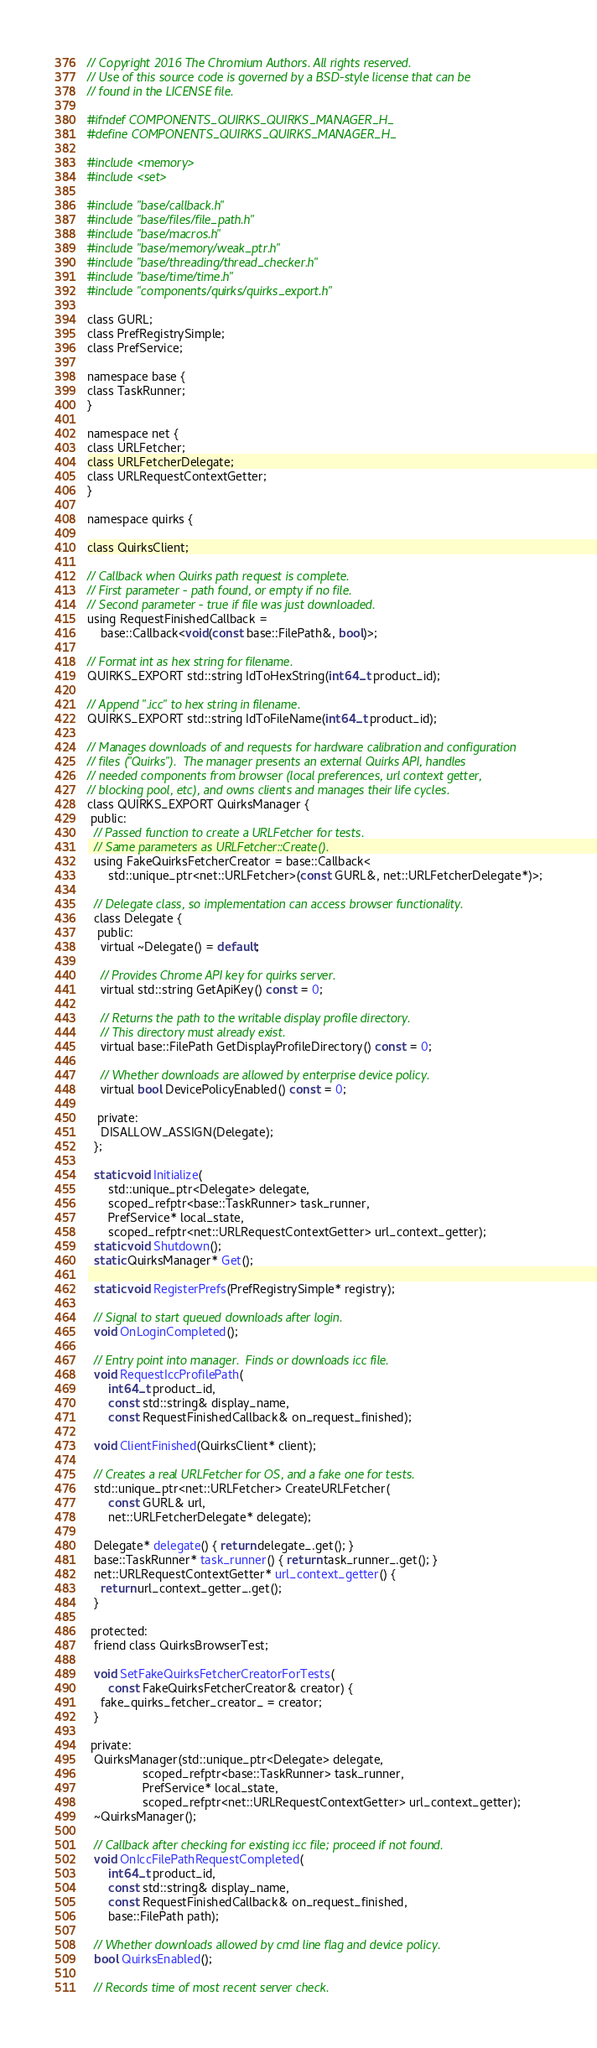Convert code to text. <code><loc_0><loc_0><loc_500><loc_500><_C_>// Copyright 2016 The Chromium Authors. All rights reserved.
// Use of this source code is governed by a BSD-style license that can be
// found in the LICENSE file.

#ifndef COMPONENTS_QUIRKS_QUIRKS_MANAGER_H_
#define COMPONENTS_QUIRKS_QUIRKS_MANAGER_H_

#include <memory>
#include <set>

#include "base/callback.h"
#include "base/files/file_path.h"
#include "base/macros.h"
#include "base/memory/weak_ptr.h"
#include "base/threading/thread_checker.h"
#include "base/time/time.h"
#include "components/quirks/quirks_export.h"

class GURL;
class PrefRegistrySimple;
class PrefService;

namespace base {
class TaskRunner;
}

namespace net {
class URLFetcher;
class URLFetcherDelegate;
class URLRequestContextGetter;
}

namespace quirks {

class QuirksClient;

// Callback when Quirks path request is complete.
// First parameter - path found, or empty if no file.
// Second parameter - true if file was just downloaded.
using RequestFinishedCallback =
    base::Callback<void(const base::FilePath&, bool)>;

// Format int as hex string for filename.
QUIRKS_EXPORT std::string IdToHexString(int64_t product_id);

// Append ".icc" to hex string in filename.
QUIRKS_EXPORT std::string IdToFileName(int64_t product_id);

// Manages downloads of and requests for hardware calibration and configuration
// files ("Quirks").  The manager presents an external Quirks API, handles
// needed components from browser (local preferences, url context getter,
// blocking pool, etc), and owns clients and manages their life cycles.
class QUIRKS_EXPORT QuirksManager {
 public:
  // Passed function to create a URLFetcher for tests.
  // Same parameters as URLFetcher::Create().
  using FakeQuirksFetcherCreator = base::Callback<
      std::unique_ptr<net::URLFetcher>(const GURL&, net::URLFetcherDelegate*)>;

  // Delegate class, so implementation can access browser functionality.
  class Delegate {
   public:
    virtual ~Delegate() = default;

    // Provides Chrome API key for quirks server.
    virtual std::string GetApiKey() const = 0;

    // Returns the path to the writable display profile directory.
    // This directory must already exist.
    virtual base::FilePath GetDisplayProfileDirectory() const = 0;

    // Whether downloads are allowed by enterprise device policy.
    virtual bool DevicePolicyEnabled() const = 0;

   private:
    DISALLOW_ASSIGN(Delegate);
  };

  static void Initialize(
      std::unique_ptr<Delegate> delegate,
      scoped_refptr<base::TaskRunner> task_runner,
      PrefService* local_state,
      scoped_refptr<net::URLRequestContextGetter> url_context_getter);
  static void Shutdown();
  static QuirksManager* Get();

  static void RegisterPrefs(PrefRegistrySimple* registry);

  // Signal to start queued downloads after login.
  void OnLoginCompleted();

  // Entry point into manager.  Finds or downloads icc file.
  void RequestIccProfilePath(
      int64_t product_id,
      const std::string& display_name,
      const RequestFinishedCallback& on_request_finished);

  void ClientFinished(QuirksClient* client);

  // Creates a real URLFetcher for OS, and a fake one for tests.
  std::unique_ptr<net::URLFetcher> CreateURLFetcher(
      const GURL& url,
      net::URLFetcherDelegate* delegate);

  Delegate* delegate() { return delegate_.get(); }
  base::TaskRunner* task_runner() { return task_runner_.get(); }
  net::URLRequestContextGetter* url_context_getter() {
    return url_context_getter_.get();
  }

 protected:
  friend class QuirksBrowserTest;

  void SetFakeQuirksFetcherCreatorForTests(
      const FakeQuirksFetcherCreator& creator) {
    fake_quirks_fetcher_creator_ = creator;
  }

 private:
  QuirksManager(std::unique_ptr<Delegate> delegate,
                scoped_refptr<base::TaskRunner> task_runner,
                PrefService* local_state,
                scoped_refptr<net::URLRequestContextGetter> url_context_getter);
  ~QuirksManager();

  // Callback after checking for existing icc file; proceed if not found.
  void OnIccFilePathRequestCompleted(
      int64_t product_id,
      const std::string& display_name,
      const RequestFinishedCallback& on_request_finished,
      base::FilePath path);

  // Whether downloads allowed by cmd line flag and device policy.
  bool QuirksEnabled();

  // Records time of most recent server check.</code> 